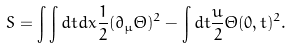Convert formula to latex. <formula><loc_0><loc_0><loc_500><loc_500>S = \int \int d t d x \frac { 1 } { 2 } ( \partial _ { \mu } \Theta ) ^ { 2 } - \int d t \frac { u } { 2 } \Theta ( 0 , t ) ^ { 2 } .</formula> 